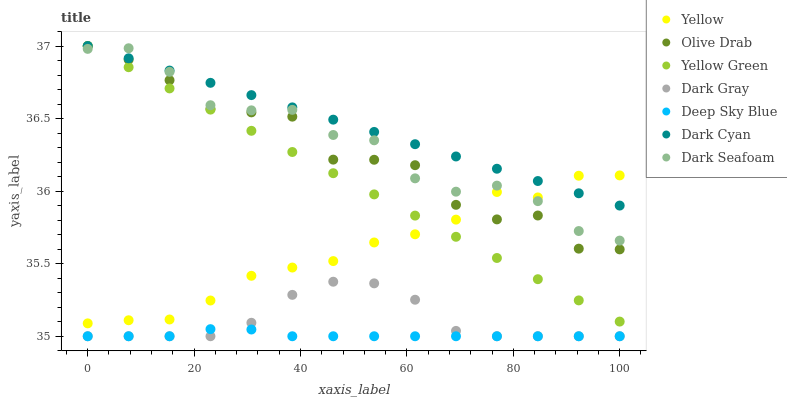Does Deep Sky Blue have the minimum area under the curve?
Answer yes or no. Yes. Does Dark Cyan have the maximum area under the curve?
Answer yes or no. Yes. Does Yellow have the minimum area under the curve?
Answer yes or no. No. Does Yellow have the maximum area under the curve?
Answer yes or no. No. Is Dark Cyan the smoothest?
Answer yes or no. Yes. Is Olive Drab the roughest?
Answer yes or no. Yes. Is Yellow the smoothest?
Answer yes or no. No. Is Yellow the roughest?
Answer yes or no. No. Does Dark Gray have the lowest value?
Answer yes or no. Yes. Does Yellow have the lowest value?
Answer yes or no. No. Does Olive Drab have the highest value?
Answer yes or no. Yes. Does Yellow have the highest value?
Answer yes or no. No. Is Dark Gray less than Dark Seafoam?
Answer yes or no. Yes. Is Yellow greater than Dark Gray?
Answer yes or no. Yes. Does Dark Cyan intersect Yellow?
Answer yes or no. Yes. Is Dark Cyan less than Yellow?
Answer yes or no. No. Is Dark Cyan greater than Yellow?
Answer yes or no. No. Does Dark Gray intersect Dark Seafoam?
Answer yes or no. No. 